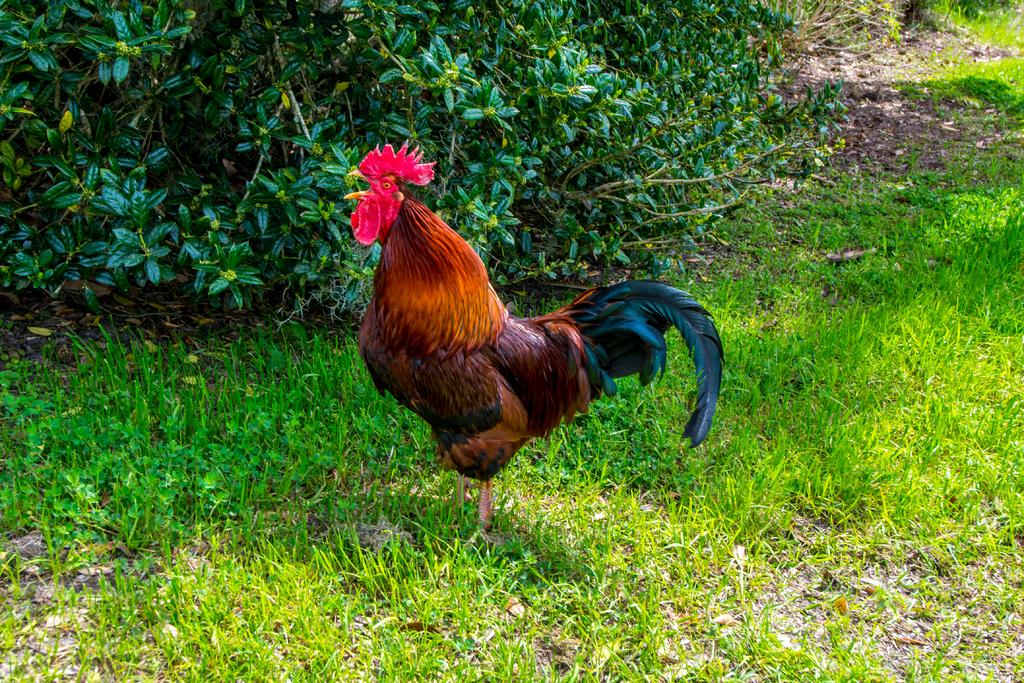What is the main object in the middle of the image? There is a roaster in the middle of the image. What type of environment is depicted in the image? The image shows grass and plants, suggesting an outdoor setting. What type of lamp is on the judge's desk in the image? There is no judge, desk, or lamp present in the image. 